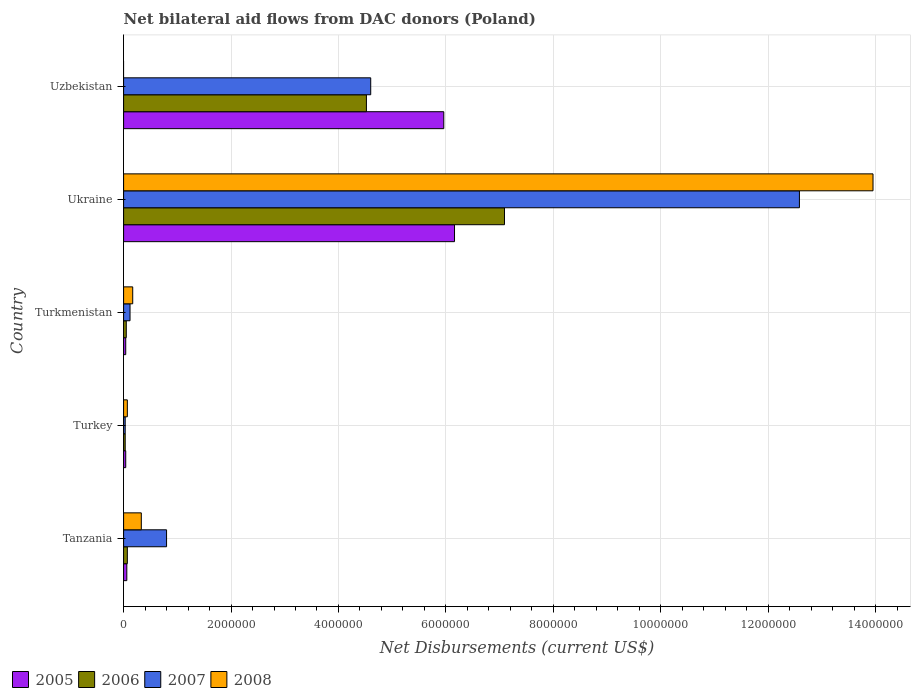How many groups of bars are there?
Make the answer very short. 5. What is the label of the 1st group of bars from the top?
Keep it short and to the point. Uzbekistan. In how many cases, is the number of bars for a given country not equal to the number of legend labels?
Keep it short and to the point. 1. What is the net bilateral aid flows in 2007 in Ukraine?
Your response must be concise. 1.26e+07. Across all countries, what is the maximum net bilateral aid flows in 2007?
Your answer should be compact. 1.26e+07. In which country was the net bilateral aid flows in 2006 maximum?
Ensure brevity in your answer.  Ukraine. What is the total net bilateral aid flows in 2005 in the graph?
Your response must be concise. 1.23e+07. What is the difference between the net bilateral aid flows in 2008 in Uzbekistan and the net bilateral aid flows in 2006 in Ukraine?
Ensure brevity in your answer.  -7.09e+06. What is the average net bilateral aid flows in 2005 per country?
Make the answer very short. 2.45e+06. What is the difference between the net bilateral aid flows in 2007 and net bilateral aid flows in 2005 in Tanzania?
Your answer should be very brief. 7.40e+05. In how many countries, is the net bilateral aid flows in 2006 greater than 7600000 US$?
Make the answer very short. 0. What is the ratio of the net bilateral aid flows in 2007 in Ukraine to that in Uzbekistan?
Ensure brevity in your answer.  2.73. What is the difference between the highest and the second highest net bilateral aid flows in 2006?
Give a very brief answer. 2.57e+06. What is the difference between the highest and the lowest net bilateral aid flows in 2006?
Make the answer very short. 7.06e+06. Is it the case that in every country, the sum of the net bilateral aid flows in 2005 and net bilateral aid flows in 2007 is greater than the sum of net bilateral aid flows in 2006 and net bilateral aid flows in 2008?
Your answer should be very brief. No. Are all the bars in the graph horizontal?
Make the answer very short. Yes. How many countries are there in the graph?
Offer a very short reply. 5. Does the graph contain grids?
Keep it short and to the point. Yes. Where does the legend appear in the graph?
Provide a succinct answer. Bottom left. How many legend labels are there?
Keep it short and to the point. 4. What is the title of the graph?
Your answer should be very brief. Net bilateral aid flows from DAC donors (Poland). Does "1999" appear as one of the legend labels in the graph?
Offer a very short reply. No. What is the label or title of the X-axis?
Your response must be concise. Net Disbursements (current US$). What is the Net Disbursements (current US$) in 2006 in Tanzania?
Your response must be concise. 7.00e+04. What is the Net Disbursements (current US$) in 2007 in Tanzania?
Your answer should be compact. 8.00e+05. What is the Net Disbursements (current US$) of 2008 in Tanzania?
Give a very brief answer. 3.30e+05. What is the Net Disbursements (current US$) in 2006 in Turkey?
Offer a very short reply. 3.00e+04. What is the Net Disbursements (current US$) of 2007 in Turkmenistan?
Your response must be concise. 1.20e+05. What is the Net Disbursements (current US$) in 2008 in Turkmenistan?
Offer a terse response. 1.70e+05. What is the Net Disbursements (current US$) of 2005 in Ukraine?
Offer a terse response. 6.16e+06. What is the Net Disbursements (current US$) in 2006 in Ukraine?
Offer a terse response. 7.09e+06. What is the Net Disbursements (current US$) in 2007 in Ukraine?
Provide a short and direct response. 1.26e+07. What is the Net Disbursements (current US$) in 2008 in Ukraine?
Provide a succinct answer. 1.40e+07. What is the Net Disbursements (current US$) of 2005 in Uzbekistan?
Keep it short and to the point. 5.96e+06. What is the Net Disbursements (current US$) of 2006 in Uzbekistan?
Offer a very short reply. 4.52e+06. What is the Net Disbursements (current US$) in 2007 in Uzbekistan?
Ensure brevity in your answer.  4.60e+06. Across all countries, what is the maximum Net Disbursements (current US$) in 2005?
Keep it short and to the point. 6.16e+06. Across all countries, what is the maximum Net Disbursements (current US$) of 2006?
Make the answer very short. 7.09e+06. Across all countries, what is the maximum Net Disbursements (current US$) of 2007?
Give a very brief answer. 1.26e+07. Across all countries, what is the maximum Net Disbursements (current US$) of 2008?
Provide a succinct answer. 1.40e+07. Across all countries, what is the minimum Net Disbursements (current US$) in 2006?
Provide a short and direct response. 3.00e+04. Across all countries, what is the minimum Net Disbursements (current US$) of 2007?
Ensure brevity in your answer.  3.00e+04. Across all countries, what is the minimum Net Disbursements (current US$) of 2008?
Your answer should be very brief. 0. What is the total Net Disbursements (current US$) in 2005 in the graph?
Provide a succinct answer. 1.23e+07. What is the total Net Disbursements (current US$) of 2006 in the graph?
Offer a terse response. 1.18e+07. What is the total Net Disbursements (current US$) in 2007 in the graph?
Your answer should be very brief. 1.81e+07. What is the total Net Disbursements (current US$) of 2008 in the graph?
Ensure brevity in your answer.  1.45e+07. What is the difference between the Net Disbursements (current US$) in 2007 in Tanzania and that in Turkey?
Provide a short and direct response. 7.70e+05. What is the difference between the Net Disbursements (current US$) in 2007 in Tanzania and that in Turkmenistan?
Ensure brevity in your answer.  6.80e+05. What is the difference between the Net Disbursements (current US$) in 2008 in Tanzania and that in Turkmenistan?
Make the answer very short. 1.60e+05. What is the difference between the Net Disbursements (current US$) of 2005 in Tanzania and that in Ukraine?
Your response must be concise. -6.10e+06. What is the difference between the Net Disbursements (current US$) of 2006 in Tanzania and that in Ukraine?
Provide a short and direct response. -7.02e+06. What is the difference between the Net Disbursements (current US$) in 2007 in Tanzania and that in Ukraine?
Give a very brief answer. -1.18e+07. What is the difference between the Net Disbursements (current US$) of 2008 in Tanzania and that in Ukraine?
Offer a very short reply. -1.36e+07. What is the difference between the Net Disbursements (current US$) of 2005 in Tanzania and that in Uzbekistan?
Your answer should be compact. -5.90e+06. What is the difference between the Net Disbursements (current US$) of 2006 in Tanzania and that in Uzbekistan?
Provide a short and direct response. -4.45e+06. What is the difference between the Net Disbursements (current US$) of 2007 in Tanzania and that in Uzbekistan?
Provide a short and direct response. -3.80e+06. What is the difference between the Net Disbursements (current US$) of 2007 in Turkey and that in Turkmenistan?
Your answer should be very brief. -9.00e+04. What is the difference between the Net Disbursements (current US$) in 2005 in Turkey and that in Ukraine?
Make the answer very short. -6.12e+06. What is the difference between the Net Disbursements (current US$) in 2006 in Turkey and that in Ukraine?
Offer a terse response. -7.06e+06. What is the difference between the Net Disbursements (current US$) in 2007 in Turkey and that in Ukraine?
Make the answer very short. -1.26e+07. What is the difference between the Net Disbursements (current US$) in 2008 in Turkey and that in Ukraine?
Keep it short and to the point. -1.39e+07. What is the difference between the Net Disbursements (current US$) in 2005 in Turkey and that in Uzbekistan?
Make the answer very short. -5.92e+06. What is the difference between the Net Disbursements (current US$) of 2006 in Turkey and that in Uzbekistan?
Your answer should be compact. -4.49e+06. What is the difference between the Net Disbursements (current US$) in 2007 in Turkey and that in Uzbekistan?
Your response must be concise. -4.57e+06. What is the difference between the Net Disbursements (current US$) in 2005 in Turkmenistan and that in Ukraine?
Provide a succinct answer. -6.12e+06. What is the difference between the Net Disbursements (current US$) in 2006 in Turkmenistan and that in Ukraine?
Offer a terse response. -7.04e+06. What is the difference between the Net Disbursements (current US$) in 2007 in Turkmenistan and that in Ukraine?
Provide a succinct answer. -1.25e+07. What is the difference between the Net Disbursements (current US$) of 2008 in Turkmenistan and that in Ukraine?
Make the answer very short. -1.38e+07. What is the difference between the Net Disbursements (current US$) in 2005 in Turkmenistan and that in Uzbekistan?
Provide a succinct answer. -5.92e+06. What is the difference between the Net Disbursements (current US$) in 2006 in Turkmenistan and that in Uzbekistan?
Keep it short and to the point. -4.47e+06. What is the difference between the Net Disbursements (current US$) in 2007 in Turkmenistan and that in Uzbekistan?
Offer a very short reply. -4.48e+06. What is the difference between the Net Disbursements (current US$) of 2006 in Ukraine and that in Uzbekistan?
Make the answer very short. 2.57e+06. What is the difference between the Net Disbursements (current US$) in 2007 in Ukraine and that in Uzbekistan?
Give a very brief answer. 7.98e+06. What is the difference between the Net Disbursements (current US$) in 2005 in Tanzania and the Net Disbursements (current US$) in 2006 in Turkey?
Provide a succinct answer. 3.00e+04. What is the difference between the Net Disbursements (current US$) of 2005 in Tanzania and the Net Disbursements (current US$) of 2007 in Turkey?
Offer a terse response. 3.00e+04. What is the difference between the Net Disbursements (current US$) in 2005 in Tanzania and the Net Disbursements (current US$) in 2008 in Turkey?
Provide a short and direct response. -10000. What is the difference between the Net Disbursements (current US$) of 2006 in Tanzania and the Net Disbursements (current US$) of 2007 in Turkey?
Your response must be concise. 4.00e+04. What is the difference between the Net Disbursements (current US$) in 2006 in Tanzania and the Net Disbursements (current US$) in 2008 in Turkey?
Offer a very short reply. 0. What is the difference between the Net Disbursements (current US$) of 2007 in Tanzania and the Net Disbursements (current US$) of 2008 in Turkey?
Provide a succinct answer. 7.30e+05. What is the difference between the Net Disbursements (current US$) of 2005 in Tanzania and the Net Disbursements (current US$) of 2006 in Turkmenistan?
Keep it short and to the point. 10000. What is the difference between the Net Disbursements (current US$) of 2005 in Tanzania and the Net Disbursements (current US$) of 2007 in Turkmenistan?
Give a very brief answer. -6.00e+04. What is the difference between the Net Disbursements (current US$) of 2005 in Tanzania and the Net Disbursements (current US$) of 2008 in Turkmenistan?
Your response must be concise. -1.10e+05. What is the difference between the Net Disbursements (current US$) in 2006 in Tanzania and the Net Disbursements (current US$) in 2007 in Turkmenistan?
Offer a very short reply. -5.00e+04. What is the difference between the Net Disbursements (current US$) in 2007 in Tanzania and the Net Disbursements (current US$) in 2008 in Turkmenistan?
Ensure brevity in your answer.  6.30e+05. What is the difference between the Net Disbursements (current US$) of 2005 in Tanzania and the Net Disbursements (current US$) of 2006 in Ukraine?
Make the answer very short. -7.03e+06. What is the difference between the Net Disbursements (current US$) of 2005 in Tanzania and the Net Disbursements (current US$) of 2007 in Ukraine?
Your response must be concise. -1.25e+07. What is the difference between the Net Disbursements (current US$) of 2005 in Tanzania and the Net Disbursements (current US$) of 2008 in Ukraine?
Ensure brevity in your answer.  -1.39e+07. What is the difference between the Net Disbursements (current US$) of 2006 in Tanzania and the Net Disbursements (current US$) of 2007 in Ukraine?
Offer a terse response. -1.25e+07. What is the difference between the Net Disbursements (current US$) of 2006 in Tanzania and the Net Disbursements (current US$) of 2008 in Ukraine?
Ensure brevity in your answer.  -1.39e+07. What is the difference between the Net Disbursements (current US$) in 2007 in Tanzania and the Net Disbursements (current US$) in 2008 in Ukraine?
Give a very brief answer. -1.32e+07. What is the difference between the Net Disbursements (current US$) in 2005 in Tanzania and the Net Disbursements (current US$) in 2006 in Uzbekistan?
Provide a succinct answer. -4.46e+06. What is the difference between the Net Disbursements (current US$) of 2005 in Tanzania and the Net Disbursements (current US$) of 2007 in Uzbekistan?
Offer a terse response. -4.54e+06. What is the difference between the Net Disbursements (current US$) in 2006 in Tanzania and the Net Disbursements (current US$) in 2007 in Uzbekistan?
Make the answer very short. -4.53e+06. What is the difference between the Net Disbursements (current US$) of 2005 in Turkey and the Net Disbursements (current US$) of 2006 in Turkmenistan?
Your answer should be very brief. -10000. What is the difference between the Net Disbursements (current US$) in 2005 in Turkey and the Net Disbursements (current US$) in 2007 in Turkmenistan?
Ensure brevity in your answer.  -8.00e+04. What is the difference between the Net Disbursements (current US$) of 2005 in Turkey and the Net Disbursements (current US$) of 2008 in Turkmenistan?
Provide a succinct answer. -1.30e+05. What is the difference between the Net Disbursements (current US$) in 2006 in Turkey and the Net Disbursements (current US$) in 2008 in Turkmenistan?
Offer a terse response. -1.40e+05. What is the difference between the Net Disbursements (current US$) of 2005 in Turkey and the Net Disbursements (current US$) of 2006 in Ukraine?
Give a very brief answer. -7.05e+06. What is the difference between the Net Disbursements (current US$) of 2005 in Turkey and the Net Disbursements (current US$) of 2007 in Ukraine?
Give a very brief answer. -1.25e+07. What is the difference between the Net Disbursements (current US$) in 2005 in Turkey and the Net Disbursements (current US$) in 2008 in Ukraine?
Provide a succinct answer. -1.39e+07. What is the difference between the Net Disbursements (current US$) in 2006 in Turkey and the Net Disbursements (current US$) in 2007 in Ukraine?
Provide a short and direct response. -1.26e+07. What is the difference between the Net Disbursements (current US$) of 2006 in Turkey and the Net Disbursements (current US$) of 2008 in Ukraine?
Provide a succinct answer. -1.39e+07. What is the difference between the Net Disbursements (current US$) of 2007 in Turkey and the Net Disbursements (current US$) of 2008 in Ukraine?
Keep it short and to the point. -1.39e+07. What is the difference between the Net Disbursements (current US$) in 2005 in Turkey and the Net Disbursements (current US$) in 2006 in Uzbekistan?
Your answer should be compact. -4.48e+06. What is the difference between the Net Disbursements (current US$) of 2005 in Turkey and the Net Disbursements (current US$) of 2007 in Uzbekistan?
Your response must be concise. -4.56e+06. What is the difference between the Net Disbursements (current US$) in 2006 in Turkey and the Net Disbursements (current US$) in 2007 in Uzbekistan?
Provide a succinct answer. -4.57e+06. What is the difference between the Net Disbursements (current US$) in 2005 in Turkmenistan and the Net Disbursements (current US$) in 2006 in Ukraine?
Give a very brief answer. -7.05e+06. What is the difference between the Net Disbursements (current US$) in 2005 in Turkmenistan and the Net Disbursements (current US$) in 2007 in Ukraine?
Make the answer very short. -1.25e+07. What is the difference between the Net Disbursements (current US$) of 2005 in Turkmenistan and the Net Disbursements (current US$) of 2008 in Ukraine?
Your answer should be compact. -1.39e+07. What is the difference between the Net Disbursements (current US$) of 2006 in Turkmenistan and the Net Disbursements (current US$) of 2007 in Ukraine?
Give a very brief answer. -1.25e+07. What is the difference between the Net Disbursements (current US$) in 2006 in Turkmenistan and the Net Disbursements (current US$) in 2008 in Ukraine?
Offer a terse response. -1.39e+07. What is the difference between the Net Disbursements (current US$) of 2007 in Turkmenistan and the Net Disbursements (current US$) of 2008 in Ukraine?
Make the answer very short. -1.38e+07. What is the difference between the Net Disbursements (current US$) of 2005 in Turkmenistan and the Net Disbursements (current US$) of 2006 in Uzbekistan?
Provide a succinct answer. -4.48e+06. What is the difference between the Net Disbursements (current US$) in 2005 in Turkmenistan and the Net Disbursements (current US$) in 2007 in Uzbekistan?
Your answer should be compact. -4.56e+06. What is the difference between the Net Disbursements (current US$) of 2006 in Turkmenistan and the Net Disbursements (current US$) of 2007 in Uzbekistan?
Provide a succinct answer. -4.55e+06. What is the difference between the Net Disbursements (current US$) of 2005 in Ukraine and the Net Disbursements (current US$) of 2006 in Uzbekistan?
Your response must be concise. 1.64e+06. What is the difference between the Net Disbursements (current US$) in 2005 in Ukraine and the Net Disbursements (current US$) in 2007 in Uzbekistan?
Make the answer very short. 1.56e+06. What is the difference between the Net Disbursements (current US$) in 2006 in Ukraine and the Net Disbursements (current US$) in 2007 in Uzbekistan?
Your answer should be very brief. 2.49e+06. What is the average Net Disbursements (current US$) of 2005 per country?
Your response must be concise. 2.45e+06. What is the average Net Disbursements (current US$) in 2006 per country?
Give a very brief answer. 2.35e+06. What is the average Net Disbursements (current US$) of 2007 per country?
Make the answer very short. 3.63e+06. What is the average Net Disbursements (current US$) of 2008 per country?
Offer a very short reply. 2.90e+06. What is the difference between the Net Disbursements (current US$) of 2005 and Net Disbursements (current US$) of 2007 in Tanzania?
Your answer should be compact. -7.40e+05. What is the difference between the Net Disbursements (current US$) in 2005 and Net Disbursements (current US$) in 2008 in Tanzania?
Offer a very short reply. -2.70e+05. What is the difference between the Net Disbursements (current US$) of 2006 and Net Disbursements (current US$) of 2007 in Tanzania?
Your response must be concise. -7.30e+05. What is the difference between the Net Disbursements (current US$) in 2006 and Net Disbursements (current US$) in 2008 in Tanzania?
Ensure brevity in your answer.  -2.60e+05. What is the difference between the Net Disbursements (current US$) in 2007 and Net Disbursements (current US$) in 2008 in Tanzania?
Your response must be concise. 4.70e+05. What is the difference between the Net Disbursements (current US$) in 2005 and Net Disbursements (current US$) in 2006 in Turkey?
Provide a succinct answer. 10000. What is the difference between the Net Disbursements (current US$) in 2005 and Net Disbursements (current US$) in 2007 in Turkey?
Provide a succinct answer. 10000. What is the difference between the Net Disbursements (current US$) in 2005 and Net Disbursements (current US$) in 2008 in Turkey?
Offer a terse response. -3.00e+04. What is the difference between the Net Disbursements (current US$) of 2006 and Net Disbursements (current US$) of 2008 in Turkey?
Provide a succinct answer. -4.00e+04. What is the difference between the Net Disbursements (current US$) in 2007 and Net Disbursements (current US$) in 2008 in Turkey?
Offer a very short reply. -4.00e+04. What is the difference between the Net Disbursements (current US$) of 2005 and Net Disbursements (current US$) of 2006 in Turkmenistan?
Your answer should be compact. -10000. What is the difference between the Net Disbursements (current US$) of 2005 and Net Disbursements (current US$) of 2008 in Turkmenistan?
Ensure brevity in your answer.  -1.30e+05. What is the difference between the Net Disbursements (current US$) in 2006 and Net Disbursements (current US$) in 2008 in Turkmenistan?
Keep it short and to the point. -1.20e+05. What is the difference between the Net Disbursements (current US$) in 2007 and Net Disbursements (current US$) in 2008 in Turkmenistan?
Offer a very short reply. -5.00e+04. What is the difference between the Net Disbursements (current US$) of 2005 and Net Disbursements (current US$) of 2006 in Ukraine?
Ensure brevity in your answer.  -9.30e+05. What is the difference between the Net Disbursements (current US$) of 2005 and Net Disbursements (current US$) of 2007 in Ukraine?
Make the answer very short. -6.42e+06. What is the difference between the Net Disbursements (current US$) in 2005 and Net Disbursements (current US$) in 2008 in Ukraine?
Give a very brief answer. -7.79e+06. What is the difference between the Net Disbursements (current US$) of 2006 and Net Disbursements (current US$) of 2007 in Ukraine?
Offer a very short reply. -5.49e+06. What is the difference between the Net Disbursements (current US$) in 2006 and Net Disbursements (current US$) in 2008 in Ukraine?
Your response must be concise. -6.86e+06. What is the difference between the Net Disbursements (current US$) of 2007 and Net Disbursements (current US$) of 2008 in Ukraine?
Ensure brevity in your answer.  -1.37e+06. What is the difference between the Net Disbursements (current US$) in 2005 and Net Disbursements (current US$) in 2006 in Uzbekistan?
Provide a short and direct response. 1.44e+06. What is the difference between the Net Disbursements (current US$) in 2005 and Net Disbursements (current US$) in 2007 in Uzbekistan?
Ensure brevity in your answer.  1.36e+06. What is the ratio of the Net Disbursements (current US$) in 2006 in Tanzania to that in Turkey?
Keep it short and to the point. 2.33. What is the ratio of the Net Disbursements (current US$) of 2007 in Tanzania to that in Turkey?
Provide a succinct answer. 26.67. What is the ratio of the Net Disbursements (current US$) in 2008 in Tanzania to that in Turkey?
Offer a very short reply. 4.71. What is the ratio of the Net Disbursements (current US$) of 2005 in Tanzania to that in Turkmenistan?
Provide a short and direct response. 1.5. What is the ratio of the Net Disbursements (current US$) in 2008 in Tanzania to that in Turkmenistan?
Your answer should be compact. 1.94. What is the ratio of the Net Disbursements (current US$) in 2005 in Tanzania to that in Ukraine?
Offer a very short reply. 0.01. What is the ratio of the Net Disbursements (current US$) in 2006 in Tanzania to that in Ukraine?
Keep it short and to the point. 0.01. What is the ratio of the Net Disbursements (current US$) of 2007 in Tanzania to that in Ukraine?
Ensure brevity in your answer.  0.06. What is the ratio of the Net Disbursements (current US$) in 2008 in Tanzania to that in Ukraine?
Give a very brief answer. 0.02. What is the ratio of the Net Disbursements (current US$) of 2005 in Tanzania to that in Uzbekistan?
Keep it short and to the point. 0.01. What is the ratio of the Net Disbursements (current US$) in 2006 in Tanzania to that in Uzbekistan?
Offer a terse response. 0.02. What is the ratio of the Net Disbursements (current US$) in 2007 in Tanzania to that in Uzbekistan?
Keep it short and to the point. 0.17. What is the ratio of the Net Disbursements (current US$) of 2005 in Turkey to that in Turkmenistan?
Provide a succinct answer. 1. What is the ratio of the Net Disbursements (current US$) in 2008 in Turkey to that in Turkmenistan?
Your answer should be compact. 0.41. What is the ratio of the Net Disbursements (current US$) in 2005 in Turkey to that in Ukraine?
Provide a short and direct response. 0.01. What is the ratio of the Net Disbursements (current US$) in 2006 in Turkey to that in Ukraine?
Provide a short and direct response. 0. What is the ratio of the Net Disbursements (current US$) of 2007 in Turkey to that in Ukraine?
Provide a short and direct response. 0. What is the ratio of the Net Disbursements (current US$) in 2008 in Turkey to that in Ukraine?
Your response must be concise. 0.01. What is the ratio of the Net Disbursements (current US$) of 2005 in Turkey to that in Uzbekistan?
Make the answer very short. 0.01. What is the ratio of the Net Disbursements (current US$) of 2006 in Turkey to that in Uzbekistan?
Offer a very short reply. 0.01. What is the ratio of the Net Disbursements (current US$) in 2007 in Turkey to that in Uzbekistan?
Give a very brief answer. 0.01. What is the ratio of the Net Disbursements (current US$) in 2005 in Turkmenistan to that in Ukraine?
Your answer should be compact. 0.01. What is the ratio of the Net Disbursements (current US$) of 2006 in Turkmenistan to that in Ukraine?
Make the answer very short. 0.01. What is the ratio of the Net Disbursements (current US$) of 2007 in Turkmenistan to that in Ukraine?
Provide a short and direct response. 0.01. What is the ratio of the Net Disbursements (current US$) in 2008 in Turkmenistan to that in Ukraine?
Offer a very short reply. 0.01. What is the ratio of the Net Disbursements (current US$) of 2005 in Turkmenistan to that in Uzbekistan?
Make the answer very short. 0.01. What is the ratio of the Net Disbursements (current US$) of 2006 in Turkmenistan to that in Uzbekistan?
Provide a succinct answer. 0.01. What is the ratio of the Net Disbursements (current US$) in 2007 in Turkmenistan to that in Uzbekistan?
Make the answer very short. 0.03. What is the ratio of the Net Disbursements (current US$) in 2005 in Ukraine to that in Uzbekistan?
Offer a very short reply. 1.03. What is the ratio of the Net Disbursements (current US$) in 2006 in Ukraine to that in Uzbekistan?
Provide a short and direct response. 1.57. What is the ratio of the Net Disbursements (current US$) of 2007 in Ukraine to that in Uzbekistan?
Ensure brevity in your answer.  2.73. What is the difference between the highest and the second highest Net Disbursements (current US$) in 2006?
Make the answer very short. 2.57e+06. What is the difference between the highest and the second highest Net Disbursements (current US$) in 2007?
Keep it short and to the point. 7.98e+06. What is the difference between the highest and the second highest Net Disbursements (current US$) of 2008?
Ensure brevity in your answer.  1.36e+07. What is the difference between the highest and the lowest Net Disbursements (current US$) in 2005?
Offer a very short reply. 6.12e+06. What is the difference between the highest and the lowest Net Disbursements (current US$) of 2006?
Give a very brief answer. 7.06e+06. What is the difference between the highest and the lowest Net Disbursements (current US$) in 2007?
Your answer should be very brief. 1.26e+07. What is the difference between the highest and the lowest Net Disbursements (current US$) in 2008?
Offer a terse response. 1.40e+07. 